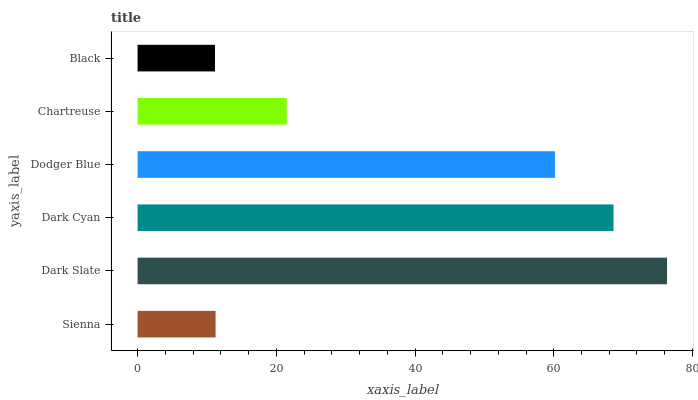Is Black the minimum?
Answer yes or no. Yes. Is Dark Slate the maximum?
Answer yes or no. Yes. Is Dark Cyan the minimum?
Answer yes or no. No. Is Dark Cyan the maximum?
Answer yes or no. No. Is Dark Slate greater than Dark Cyan?
Answer yes or no. Yes. Is Dark Cyan less than Dark Slate?
Answer yes or no. Yes. Is Dark Cyan greater than Dark Slate?
Answer yes or no. No. Is Dark Slate less than Dark Cyan?
Answer yes or no. No. Is Dodger Blue the high median?
Answer yes or no. Yes. Is Chartreuse the low median?
Answer yes or no. Yes. Is Dark Slate the high median?
Answer yes or no. No. Is Sienna the low median?
Answer yes or no. No. 